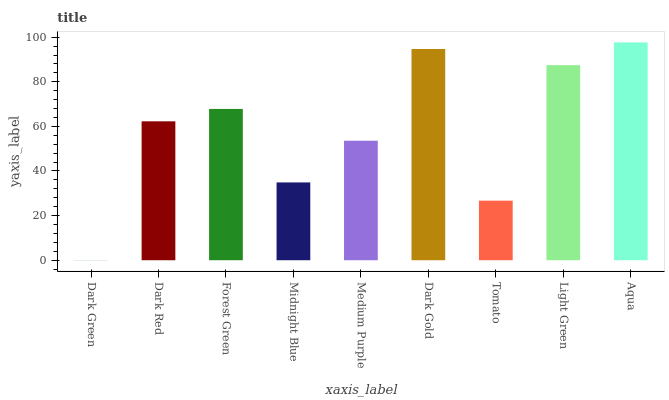Is Dark Green the minimum?
Answer yes or no. Yes. Is Aqua the maximum?
Answer yes or no. Yes. Is Dark Red the minimum?
Answer yes or no. No. Is Dark Red the maximum?
Answer yes or no. No. Is Dark Red greater than Dark Green?
Answer yes or no. Yes. Is Dark Green less than Dark Red?
Answer yes or no. Yes. Is Dark Green greater than Dark Red?
Answer yes or no. No. Is Dark Red less than Dark Green?
Answer yes or no. No. Is Dark Red the high median?
Answer yes or no. Yes. Is Dark Red the low median?
Answer yes or no. Yes. Is Dark Gold the high median?
Answer yes or no. No. Is Forest Green the low median?
Answer yes or no. No. 